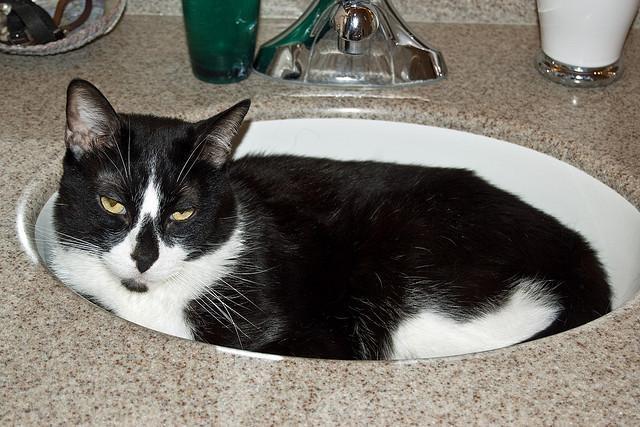How many statues on the clock have wings?
Give a very brief answer. 0. 